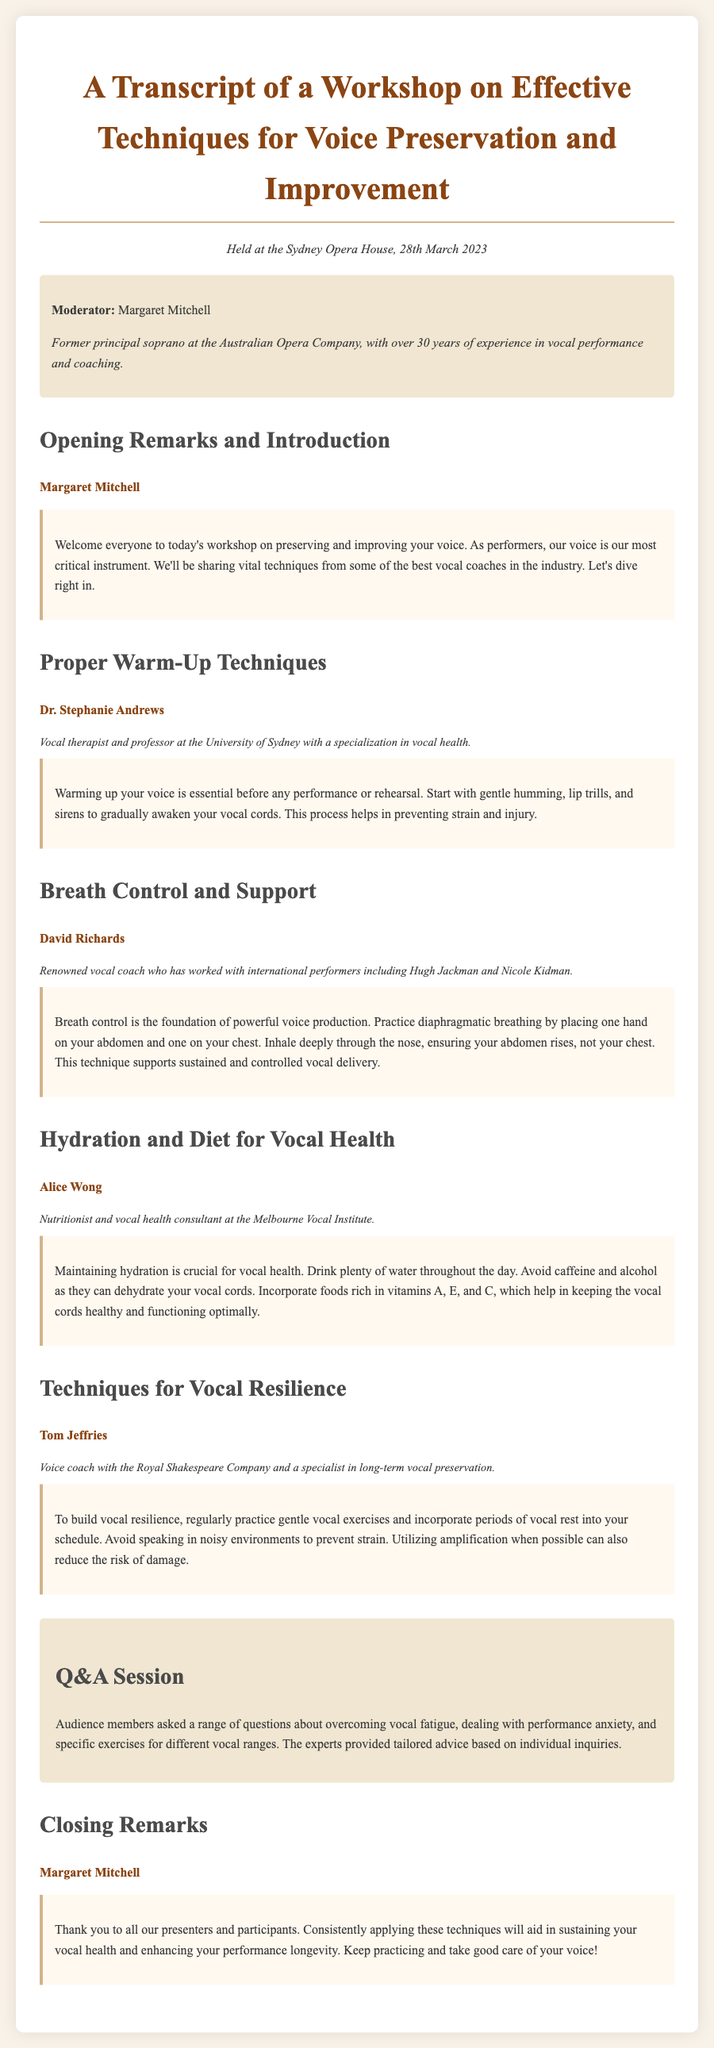What is the date of the workshop? The document states that the workshop was held on 28th March 2023.
Answer: 28th March 2023 Who moderated the workshop? The transcript mentions Margaret Mitchell as the moderator of the workshop.
Answer: Margaret Mitchell What is the primary focus of Dr. Stephanie Andrews’ section? Dr. Stephanie Andrews discusses proper warm-up techniques for vocal health.
Answer: Proper warm-up techniques What advice does David Richards give for breath control? David Richards emphasizes the importance of diaphragmatic breathing for voice production.
Answer: Diaphragmatic breathing Which nutrient-rich foods does Alice Wong recommend? Alice Wong recommends incorporating foods rich in vitamins A, E, and C for vocal health.
Answer: Vitamins A, E, and C What is one method Tom Jeffries suggests for building vocal resilience? Tom Jeffries advises practicing gentle vocal exercises regularly.
Answer: Gentle vocal exercises What type of session follows the presentations? The document indicates there is a Q&A session after the presentations.
Answer: Q&A session What is the main takeaway from Margaret Mitchell’s closing remarks? Margaret Mitchell highlights the importance of consistently applying techniques for vocal health.
Answer: Consistently applying techniques 